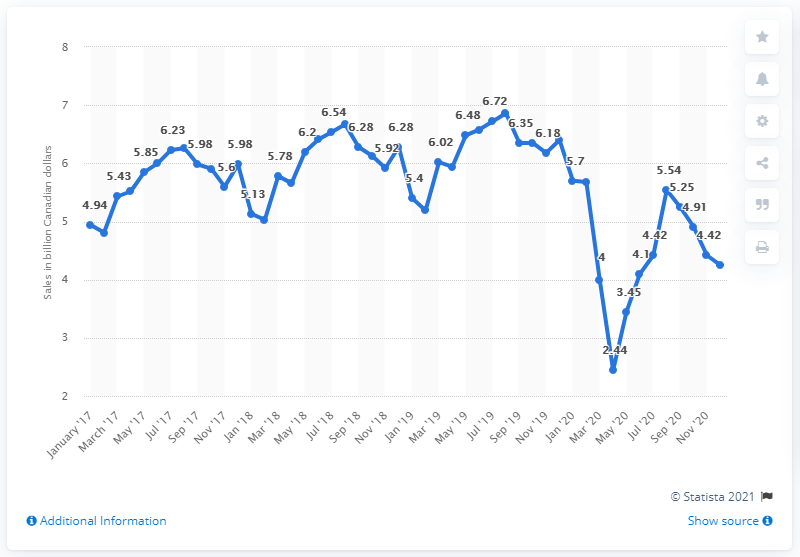Specify some key components in this picture. In December, the total sales for the food services and drinking places sector was 5.03. 